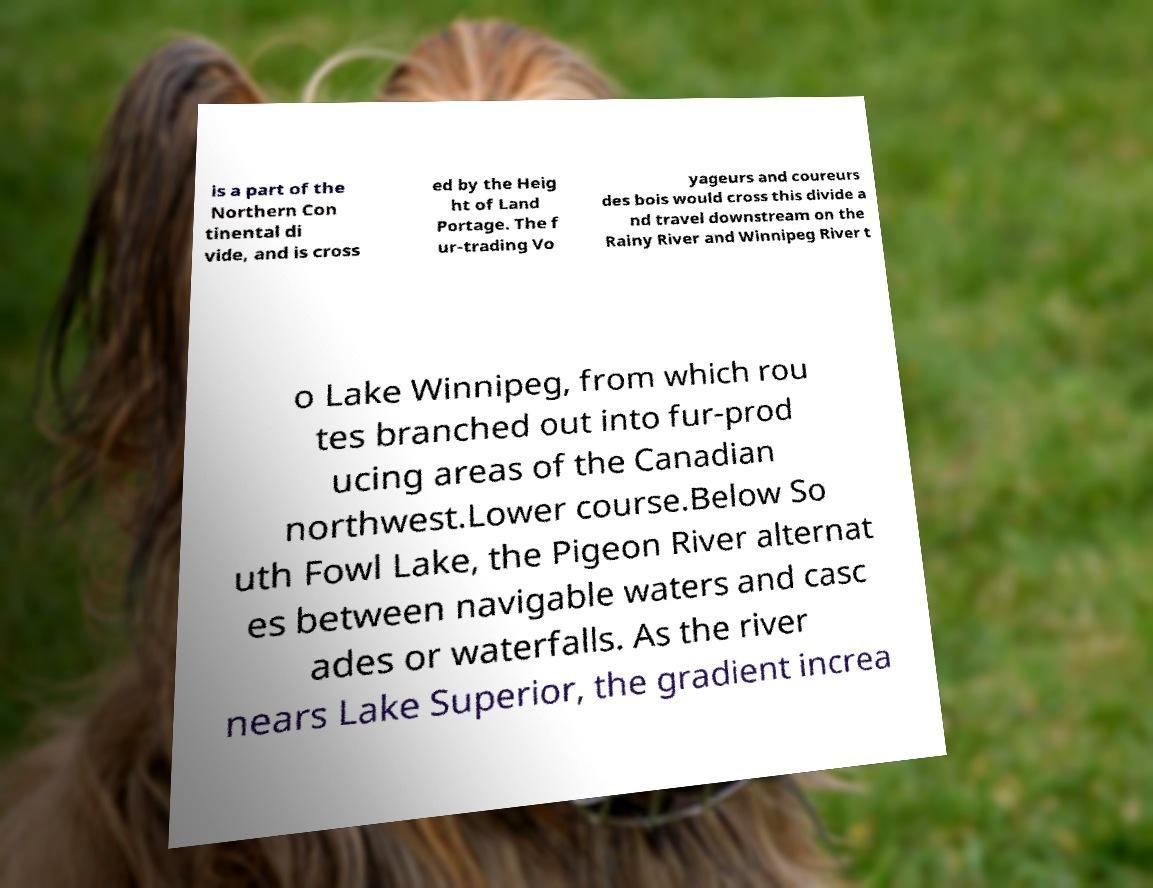What messages or text are displayed in this image? I need them in a readable, typed format. is a part of the Northern Con tinental di vide, and is cross ed by the Heig ht of Land Portage. The f ur-trading Vo yageurs and coureurs des bois would cross this divide a nd travel downstream on the Rainy River and Winnipeg River t o Lake Winnipeg, from which rou tes branched out into fur-prod ucing areas of the Canadian northwest.Lower course.Below So uth Fowl Lake, the Pigeon River alternat es between navigable waters and casc ades or waterfalls. As the river nears Lake Superior, the gradient increa 